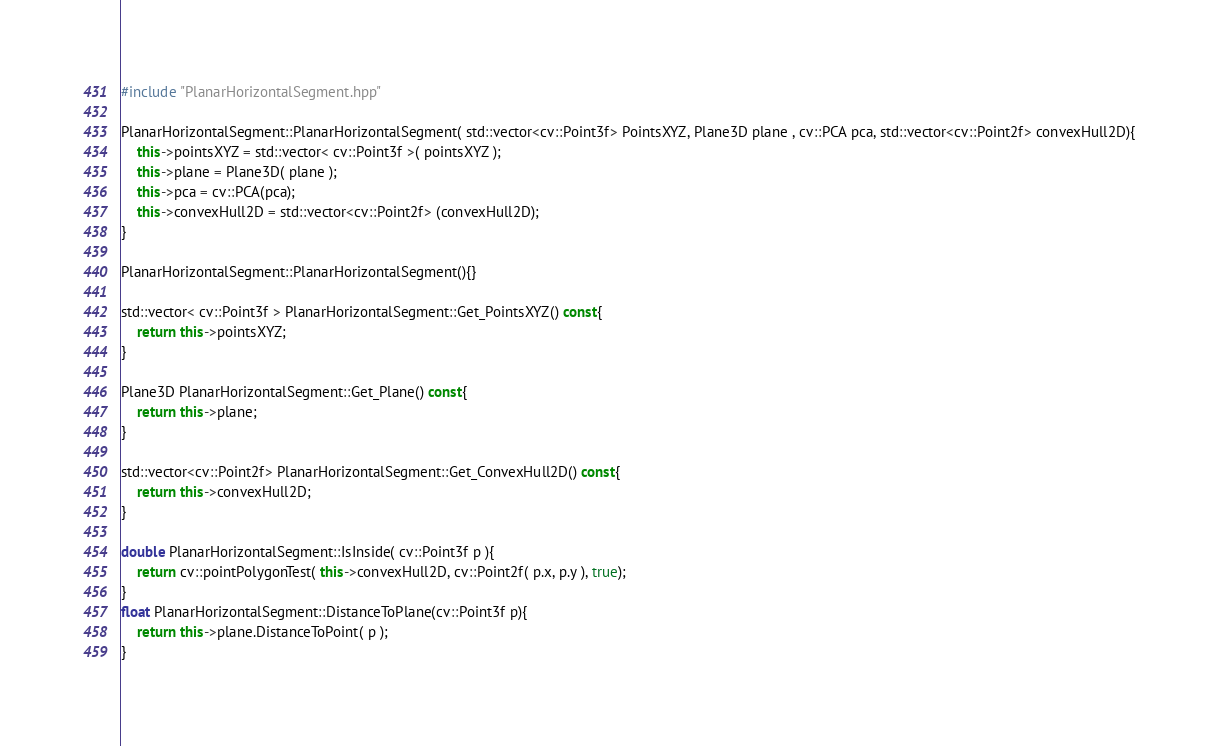<code> <loc_0><loc_0><loc_500><loc_500><_C++_>#include "PlanarHorizontalSegment.hpp"

PlanarHorizontalSegment::PlanarHorizontalSegment( std::vector<cv::Point3f> PointsXYZ, Plane3D plane , cv::PCA pca, std::vector<cv::Point2f> convexHull2D){
	this->pointsXYZ = std::vector< cv::Point3f >( pointsXYZ ); 
	this->plane = Plane3D( plane ); 
	this->pca = cv::PCA(pca); 
	this->convexHull2D = std::vector<cv::Point2f> (convexHull2D); 
}

PlanarHorizontalSegment::PlanarHorizontalSegment(){}

std::vector< cv::Point3f > PlanarHorizontalSegment::Get_PointsXYZ() const{
	return this->pointsXYZ; 
}

Plane3D PlanarHorizontalSegment::Get_Plane() const{
	return this->plane; 
}

std::vector<cv::Point2f> PlanarHorizontalSegment::Get_ConvexHull2D() const{
	return this->convexHull2D; 
}

double PlanarHorizontalSegment::IsInside( cv::Point3f p ){
	return cv::pointPolygonTest( this->convexHull2D, cv::Point2f( p.x, p.y ), true); 
}
float PlanarHorizontalSegment::DistanceToPlane(cv::Point3f p){
	return this->plane.DistanceToPoint( p ); 
}
</code> 